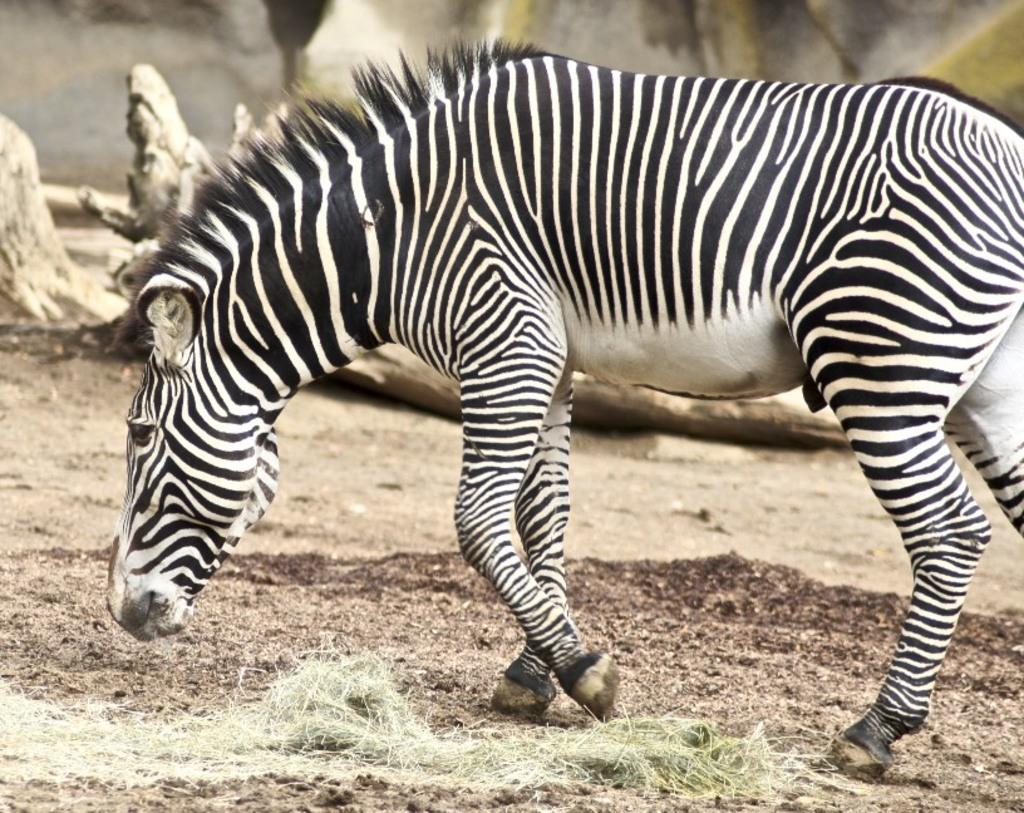What type of living creature is in the image? There is an animal in the image. What can be seen beneath the animal's feet? The ground is visible in the image. What type of vegetation is present in the image? There is grass in the image. What can be seen behind the animal? There are objects in the background of the image. What type of hospital can be seen in the background of the image? There is no hospital present in the image; it features an animal in a grassy area with objects in the background. What is the animal's desire in the image? The image does not convey the animal's desires or emotions, so it cannot be determined from the image. 